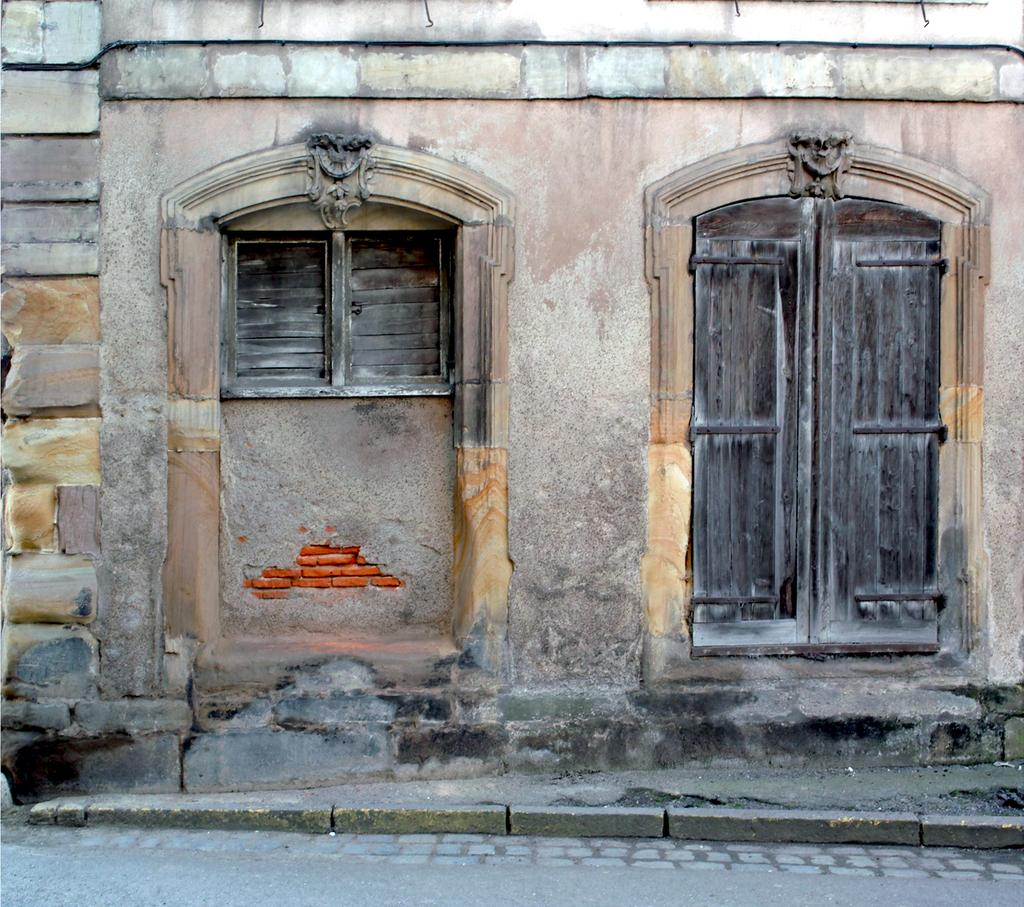What type of structure is visible in the image? There is a wall in the image. What architectural feature can be seen in the wall? There are windows in the image. What is the outdoor setting visible in the image? There is a road in the image. Where is the cemetery located in the image? There is no cemetery present in the image. What type of paste is being used to construct the wall in the image? There is no mention of any paste being used in the image; it is a wall with windows. --- 